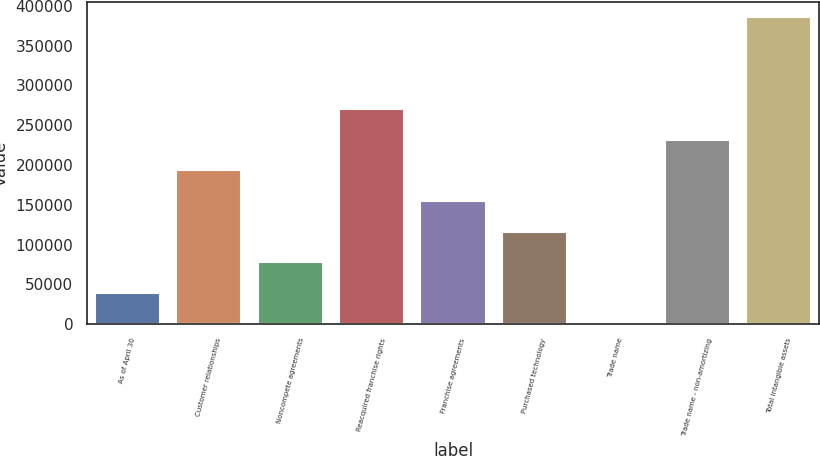<chart> <loc_0><loc_0><loc_500><loc_500><bar_chart><fcel>As of April 30<fcel>Customer relationships<fcel>Noncompete agreements<fcel>Reacquired franchise rights<fcel>Franchise agreements<fcel>Purchased technology<fcel>Trade name<fcel>Trade name - non-amortizing<fcel>Total intangible assets<nl><fcel>39327<fcel>193403<fcel>77846<fcel>270441<fcel>154884<fcel>116365<fcel>808<fcel>231922<fcel>385998<nl></chart> 